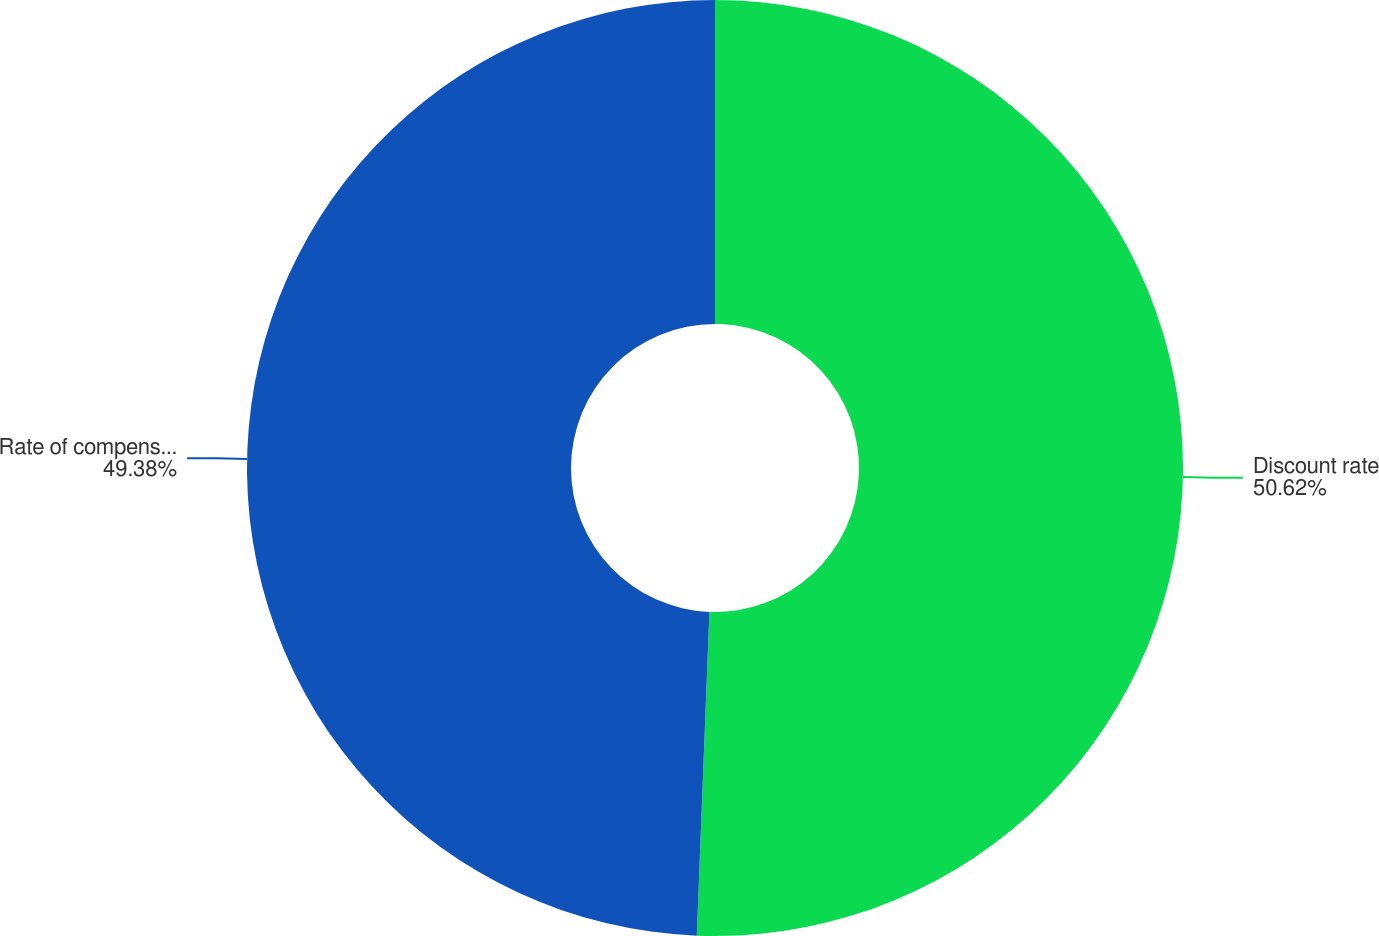Convert chart. <chart><loc_0><loc_0><loc_500><loc_500><pie_chart><fcel>Discount rate<fcel>Rate of compensation increase<nl><fcel>50.62%<fcel>49.38%<nl></chart> 